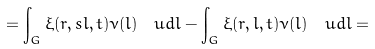<formula> <loc_0><loc_0><loc_500><loc_500>= \int _ { G } \xi ( r , s l , t ) \nu ( l ) \, { \ u d } l - \int _ { G } \xi ( r , l , t ) \nu ( l ) \, { \ u d } l =</formula> 